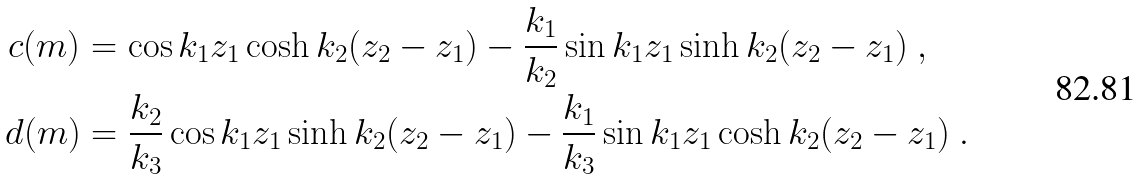Convert formula to latex. <formula><loc_0><loc_0><loc_500><loc_500>c ( m ) & = \cos k _ { 1 } z _ { 1 } \cosh k _ { 2 } ( z _ { 2 } - z _ { 1 } ) - \frac { k _ { 1 } } { k _ { 2 } } \sin k _ { 1 } z _ { 1 } \sinh k _ { 2 } ( z _ { 2 } - z _ { 1 } ) \ , \\ d ( m ) & = \frac { k _ { 2 } } { k _ { 3 } } \cos k _ { 1 } z _ { 1 } \sinh k _ { 2 } ( z _ { 2 } - z _ { 1 } ) - \frac { k _ { 1 } } { k _ { 3 } } \sin k _ { 1 } z _ { 1 } \cosh k _ { 2 } ( z _ { 2 } - z _ { 1 } ) \ .</formula> 